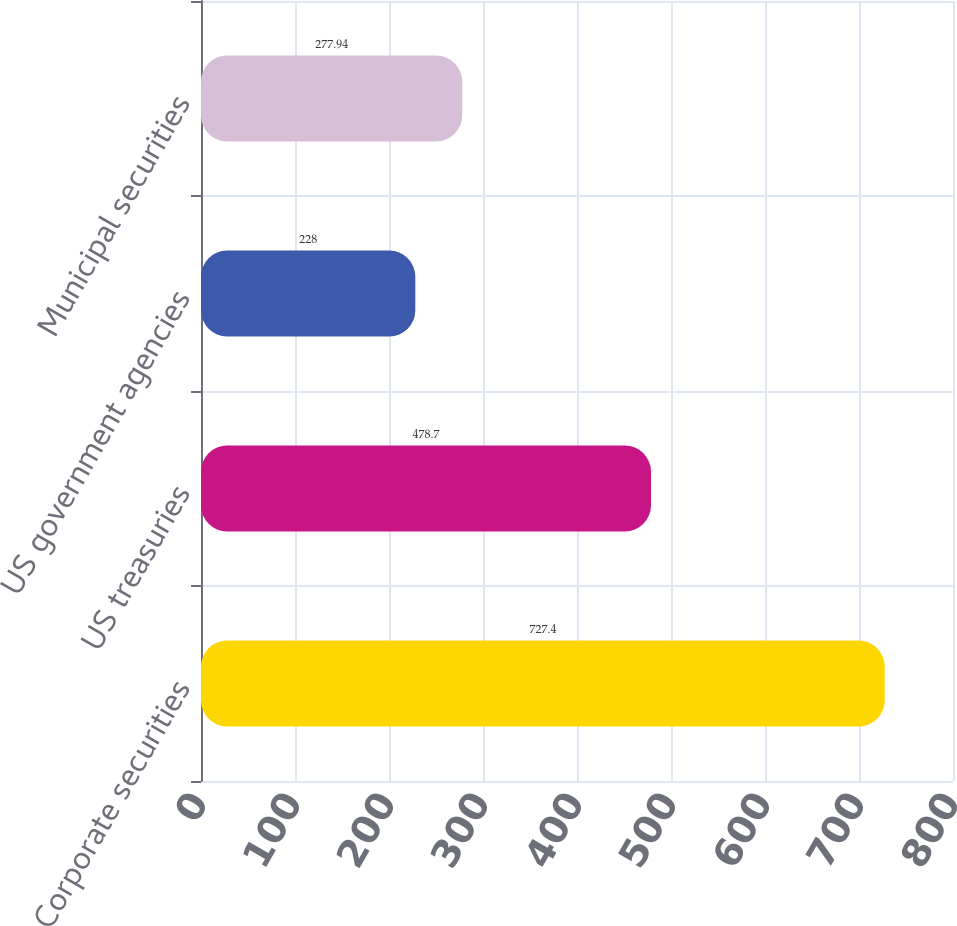Convert chart. <chart><loc_0><loc_0><loc_500><loc_500><bar_chart><fcel>Corporate securities<fcel>US treasuries<fcel>US government agencies<fcel>Municipal securities<nl><fcel>727.4<fcel>478.7<fcel>228<fcel>277.94<nl></chart> 